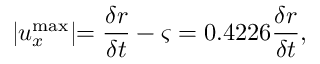Convert formula to latex. <formula><loc_0><loc_0><loc_500><loc_500>| u _ { x } ^ { \max } | = \frac { \delta r } { \delta t } - \varsigma = 0 . 4 2 2 6 \frac { \delta r } { \delta t } ,</formula> 